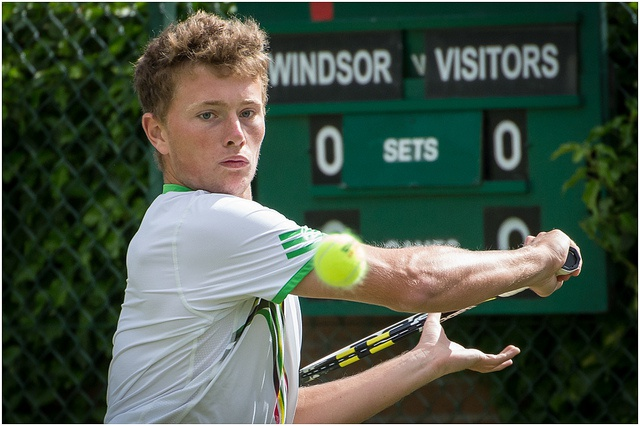Describe the objects in this image and their specific colors. I can see people in white, darkgray, gray, lightgray, and black tones, tennis racket in white, black, gray, lightgray, and darkgray tones, and sports ball in white, khaki, and ivory tones in this image. 